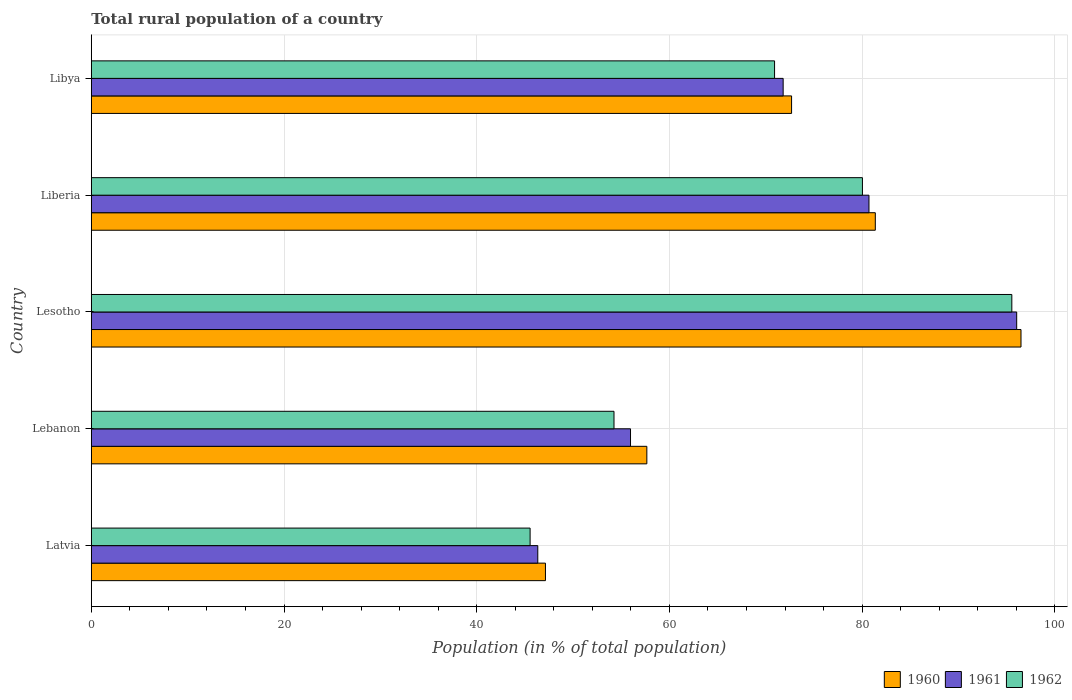How many groups of bars are there?
Provide a short and direct response. 5. Are the number of bars per tick equal to the number of legend labels?
Offer a terse response. Yes. Are the number of bars on each tick of the Y-axis equal?
Your answer should be very brief. Yes. How many bars are there on the 1st tick from the top?
Your answer should be very brief. 3. What is the label of the 4th group of bars from the top?
Give a very brief answer. Lebanon. What is the rural population in 1961 in Lesotho?
Offer a terse response. 96.04. Across all countries, what is the maximum rural population in 1961?
Your answer should be very brief. 96.04. Across all countries, what is the minimum rural population in 1961?
Your answer should be compact. 46.34. In which country was the rural population in 1962 maximum?
Ensure brevity in your answer.  Lesotho. In which country was the rural population in 1960 minimum?
Offer a terse response. Latvia. What is the total rural population in 1961 in the graph?
Provide a short and direct response. 350.85. What is the difference between the rural population in 1961 in Latvia and that in Lebanon?
Give a very brief answer. -9.62. What is the difference between the rural population in 1960 in Lesotho and the rural population in 1961 in Lebanon?
Make the answer very short. 40.53. What is the average rural population in 1960 per country?
Your answer should be very brief. 71.06. What is the difference between the rural population in 1960 and rural population in 1962 in Lebanon?
Your answer should be compact. 3.41. What is the ratio of the rural population in 1961 in Liberia to that in Libya?
Your response must be concise. 1.12. Is the difference between the rural population in 1960 in Lesotho and Liberia greater than the difference between the rural population in 1962 in Lesotho and Liberia?
Provide a succinct answer. No. What is the difference between the highest and the second highest rural population in 1961?
Provide a succinct answer. 15.33. What is the difference between the highest and the lowest rural population in 1962?
Ensure brevity in your answer.  50. In how many countries, is the rural population in 1960 greater than the average rural population in 1960 taken over all countries?
Make the answer very short. 3. Is the sum of the rural population in 1960 in Lesotho and Libya greater than the maximum rural population in 1961 across all countries?
Offer a terse response. Yes. Is it the case that in every country, the sum of the rural population in 1961 and rural population in 1960 is greater than the rural population in 1962?
Make the answer very short. Yes. How many bars are there?
Provide a succinct answer. 15. What is the difference between two consecutive major ticks on the X-axis?
Make the answer very short. 20. Does the graph contain grids?
Keep it short and to the point. Yes. How many legend labels are there?
Your answer should be compact. 3. How are the legend labels stacked?
Ensure brevity in your answer.  Horizontal. What is the title of the graph?
Your answer should be very brief. Total rural population of a country. Does "1979" appear as one of the legend labels in the graph?
Provide a short and direct response. No. What is the label or title of the X-axis?
Ensure brevity in your answer.  Population (in % of total population). What is the label or title of the Y-axis?
Provide a succinct answer. Country. What is the Population (in % of total population) of 1960 in Latvia?
Provide a short and direct response. 47.13. What is the Population (in % of total population) in 1961 in Latvia?
Make the answer very short. 46.34. What is the Population (in % of total population) of 1962 in Latvia?
Your answer should be very brief. 45.54. What is the Population (in % of total population) of 1960 in Lebanon?
Make the answer very short. 57.66. What is the Population (in % of total population) in 1961 in Lebanon?
Give a very brief answer. 55.96. What is the Population (in % of total population) in 1962 in Lebanon?
Make the answer very short. 54.25. What is the Population (in % of total population) in 1960 in Lesotho?
Your response must be concise. 96.49. What is the Population (in % of total population) in 1961 in Lesotho?
Provide a short and direct response. 96.04. What is the Population (in % of total population) in 1962 in Lesotho?
Make the answer very short. 95.54. What is the Population (in % of total population) in 1960 in Liberia?
Give a very brief answer. 81.37. What is the Population (in % of total population) in 1961 in Liberia?
Provide a succinct answer. 80.71. What is the Population (in % of total population) in 1962 in Liberia?
Keep it short and to the point. 80.03. What is the Population (in % of total population) of 1960 in Libya?
Keep it short and to the point. 72.68. What is the Population (in % of total population) of 1961 in Libya?
Your response must be concise. 71.8. What is the Population (in % of total population) in 1962 in Libya?
Your response must be concise. 70.91. Across all countries, what is the maximum Population (in % of total population) of 1960?
Keep it short and to the point. 96.49. Across all countries, what is the maximum Population (in % of total population) in 1961?
Make the answer very short. 96.04. Across all countries, what is the maximum Population (in % of total population) in 1962?
Make the answer very short. 95.54. Across all countries, what is the minimum Population (in % of total population) in 1960?
Give a very brief answer. 47.13. Across all countries, what is the minimum Population (in % of total population) of 1961?
Your answer should be compact. 46.34. Across all countries, what is the minimum Population (in % of total population) of 1962?
Offer a terse response. 45.54. What is the total Population (in % of total population) of 1960 in the graph?
Your answer should be very brief. 355.32. What is the total Population (in % of total population) of 1961 in the graph?
Offer a very short reply. 350.85. What is the total Population (in % of total population) of 1962 in the graph?
Ensure brevity in your answer.  346.27. What is the difference between the Population (in % of total population) in 1960 in Latvia and that in Lebanon?
Your answer should be very brief. -10.52. What is the difference between the Population (in % of total population) in 1961 in Latvia and that in Lebanon?
Give a very brief answer. -9.62. What is the difference between the Population (in % of total population) in 1962 in Latvia and that in Lebanon?
Offer a very short reply. -8.71. What is the difference between the Population (in % of total population) in 1960 in Latvia and that in Lesotho?
Your answer should be very brief. -49.35. What is the difference between the Population (in % of total population) in 1961 in Latvia and that in Lesotho?
Offer a very short reply. -49.7. What is the difference between the Population (in % of total population) in 1962 in Latvia and that in Lesotho?
Your response must be concise. -49.99. What is the difference between the Population (in % of total population) of 1960 in Latvia and that in Liberia?
Your answer should be compact. -34.23. What is the difference between the Population (in % of total population) in 1961 in Latvia and that in Liberia?
Ensure brevity in your answer.  -34.37. What is the difference between the Population (in % of total population) of 1962 in Latvia and that in Liberia?
Make the answer very short. -34.49. What is the difference between the Population (in % of total population) of 1960 in Latvia and that in Libya?
Provide a succinct answer. -25.54. What is the difference between the Population (in % of total population) of 1961 in Latvia and that in Libya?
Your response must be concise. -25.47. What is the difference between the Population (in % of total population) in 1962 in Latvia and that in Libya?
Offer a very short reply. -25.37. What is the difference between the Population (in % of total population) in 1960 in Lebanon and that in Lesotho?
Your answer should be compact. -38.83. What is the difference between the Population (in % of total population) of 1961 in Lebanon and that in Lesotho?
Provide a succinct answer. -40.08. What is the difference between the Population (in % of total population) in 1962 in Lebanon and that in Lesotho?
Keep it short and to the point. -41.29. What is the difference between the Population (in % of total population) of 1960 in Lebanon and that in Liberia?
Your answer should be compact. -23.71. What is the difference between the Population (in % of total population) in 1961 in Lebanon and that in Liberia?
Provide a short and direct response. -24.75. What is the difference between the Population (in % of total population) of 1962 in Lebanon and that in Liberia?
Make the answer very short. -25.78. What is the difference between the Population (in % of total population) of 1960 in Lebanon and that in Libya?
Offer a very short reply. -15.02. What is the difference between the Population (in % of total population) of 1961 in Lebanon and that in Libya?
Provide a short and direct response. -15.84. What is the difference between the Population (in % of total population) in 1962 in Lebanon and that in Libya?
Provide a short and direct response. -16.66. What is the difference between the Population (in % of total population) in 1960 in Lesotho and that in Liberia?
Your answer should be very brief. 15.12. What is the difference between the Population (in % of total population) of 1961 in Lesotho and that in Liberia?
Offer a very short reply. 15.33. What is the difference between the Population (in % of total population) in 1962 in Lesotho and that in Liberia?
Offer a very short reply. 15.51. What is the difference between the Population (in % of total population) in 1960 in Lesotho and that in Libya?
Your answer should be compact. 23.81. What is the difference between the Population (in % of total population) of 1961 in Lesotho and that in Libya?
Your response must be concise. 24.24. What is the difference between the Population (in % of total population) of 1962 in Lesotho and that in Libya?
Offer a terse response. 24.62. What is the difference between the Population (in % of total population) of 1960 in Liberia and that in Libya?
Your answer should be compact. 8.69. What is the difference between the Population (in % of total population) of 1961 in Liberia and that in Libya?
Your answer should be very brief. 8.91. What is the difference between the Population (in % of total population) of 1962 in Liberia and that in Libya?
Your response must be concise. 9.12. What is the difference between the Population (in % of total population) of 1960 in Latvia and the Population (in % of total population) of 1961 in Lebanon?
Your answer should be compact. -8.83. What is the difference between the Population (in % of total population) in 1960 in Latvia and the Population (in % of total population) in 1962 in Lebanon?
Your answer should be very brief. -7.12. What is the difference between the Population (in % of total population) of 1961 in Latvia and the Population (in % of total population) of 1962 in Lebanon?
Your response must be concise. -7.91. What is the difference between the Population (in % of total population) of 1960 in Latvia and the Population (in % of total population) of 1961 in Lesotho?
Offer a terse response. -48.91. What is the difference between the Population (in % of total population) in 1960 in Latvia and the Population (in % of total population) in 1962 in Lesotho?
Offer a terse response. -48.4. What is the difference between the Population (in % of total population) of 1961 in Latvia and the Population (in % of total population) of 1962 in Lesotho?
Your answer should be very brief. -49.2. What is the difference between the Population (in % of total population) of 1960 in Latvia and the Population (in % of total population) of 1961 in Liberia?
Provide a succinct answer. -33.58. What is the difference between the Population (in % of total population) in 1960 in Latvia and the Population (in % of total population) in 1962 in Liberia?
Your answer should be compact. -32.9. What is the difference between the Population (in % of total population) of 1961 in Latvia and the Population (in % of total population) of 1962 in Liberia?
Your response must be concise. -33.69. What is the difference between the Population (in % of total population) in 1960 in Latvia and the Population (in % of total population) in 1961 in Libya?
Keep it short and to the point. -24.67. What is the difference between the Population (in % of total population) of 1960 in Latvia and the Population (in % of total population) of 1962 in Libya?
Provide a short and direct response. -23.78. What is the difference between the Population (in % of total population) of 1961 in Latvia and the Population (in % of total population) of 1962 in Libya?
Ensure brevity in your answer.  -24.57. What is the difference between the Population (in % of total population) of 1960 in Lebanon and the Population (in % of total population) of 1961 in Lesotho?
Provide a succinct answer. -38.38. What is the difference between the Population (in % of total population) in 1960 in Lebanon and the Population (in % of total population) in 1962 in Lesotho?
Provide a succinct answer. -37.88. What is the difference between the Population (in % of total population) of 1961 in Lebanon and the Population (in % of total population) of 1962 in Lesotho?
Give a very brief answer. -39.58. What is the difference between the Population (in % of total population) of 1960 in Lebanon and the Population (in % of total population) of 1961 in Liberia?
Provide a short and direct response. -23.05. What is the difference between the Population (in % of total population) in 1960 in Lebanon and the Population (in % of total population) in 1962 in Liberia?
Keep it short and to the point. -22.37. What is the difference between the Population (in % of total population) in 1961 in Lebanon and the Population (in % of total population) in 1962 in Liberia?
Make the answer very short. -24.07. What is the difference between the Population (in % of total population) of 1960 in Lebanon and the Population (in % of total population) of 1961 in Libya?
Your answer should be compact. -14.15. What is the difference between the Population (in % of total population) of 1960 in Lebanon and the Population (in % of total population) of 1962 in Libya?
Give a very brief answer. -13.25. What is the difference between the Population (in % of total population) in 1961 in Lebanon and the Population (in % of total population) in 1962 in Libya?
Offer a terse response. -14.95. What is the difference between the Population (in % of total population) of 1960 in Lesotho and the Population (in % of total population) of 1961 in Liberia?
Provide a succinct answer. 15.78. What is the difference between the Population (in % of total population) in 1960 in Lesotho and the Population (in % of total population) in 1962 in Liberia?
Provide a succinct answer. 16.46. What is the difference between the Population (in % of total population) of 1961 in Lesotho and the Population (in % of total population) of 1962 in Liberia?
Your answer should be compact. 16.01. What is the difference between the Population (in % of total population) in 1960 in Lesotho and the Population (in % of total population) in 1961 in Libya?
Keep it short and to the point. 24.68. What is the difference between the Population (in % of total population) of 1960 in Lesotho and the Population (in % of total population) of 1962 in Libya?
Provide a succinct answer. 25.58. What is the difference between the Population (in % of total population) of 1961 in Lesotho and the Population (in % of total population) of 1962 in Libya?
Keep it short and to the point. 25.13. What is the difference between the Population (in % of total population) of 1960 in Liberia and the Population (in % of total population) of 1961 in Libya?
Your response must be concise. 9.56. What is the difference between the Population (in % of total population) of 1960 in Liberia and the Population (in % of total population) of 1962 in Libya?
Your response must be concise. 10.46. What is the difference between the Population (in % of total population) of 1961 in Liberia and the Population (in % of total population) of 1962 in Libya?
Your answer should be compact. 9.8. What is the average Population (in % of total population) of 1960 per country?
Your response must be concise. 71.06. What is the average Population (in % of total population) in 1961 per country?
Offer a very short reply. 70.17. What is the average Population (in % of total population) of 1962 per country?
Ensure brevity in your answer.  69.25. What is the difference between the Population (in % of total population) in 1960 and Population (in % of total population) in 1961 in Latvia?
Provide a short and direct response. 0.8. What is the difference between the Population (in % of total population) of 1960 and Population (in % of total population) of 1962 in Latvia?
Make the answer very short. 1.59. What is the difference between the Population (in % of total population) of 1961 and Population (in % of total population) of 1962 in Latvia?
Your answer should be compact. 0.8. What is the difference between the Population (in % of total population) in 1960 and Population (in % of total population) in 1961 in Lebanon?
Offer a terse response. 1.7. What is the difference between the Population (in % of total population) of 1960 and Population (in % of total population) of 1962 in Lebanon?
Offer a terse response. 3.41. What is the difference between the Population (in % of total population) in 1961 and Population (in % of total population) in 1962 in Lebanon?
Keep it short and to the point. 1.71. What is the difference between the Population (in % of total population) of 1960 and Population (in % of total population) of 1961 in Lesotho?
Offer a terse response. 0.45. What is the difference between the Population (in % of total population) of 1960 and Population (in % of total population) of 1962 in Lesotho?
Keep it short and to the point. 0.95. What is the difference between the Population (in % of total population) in 1961 and Population (in % of total population) in 1962 in Lesotho?
Offer a very short reply. 0.5. What is the difference between the Population (in % of total population) of 1960 and Population (in % of total population) of 1961 in Liberia?
Give a very brief answer. 0.66. What is the difference between the Population (in % of total population) in 1960 and Population (in % of total population) in 1962 in Liberia?
Make the answer very short. 1.34. What is the difference between the Population (in % of total population) in 1961 and Population (in % of total population) in 1962 in Liberia?
Keep it short and to the point. 0.68. What is the difference between the Population (in % of total population) of 1960 and Population (in % of total population) of 1961 in Libya?
Ensure brevity in your answer.  0.87. What is the difference between the Population (in % of total population) in 1960 and Population (in % of total population) in 1962 in Libya?
Your response must be concise. 1.77. What is the difference between the Population (in % of total population) of 1961 and Population (in % of total population) of 1962 in Libya?
Offer a very short reply. 0.89. What is the ratio of the Population (in % of total population) in 1960 in Latvia to that in Lebanon?
Ensure brevity in your answer.  0.82. What is the ratio of the Population (in % of total population) of 1961 in Latvia to that in Lebanon?
Your answer should be compact. 0.83. What is the ratio of the Population (in % of total population) in 1962 in Latvia to that in Lebanon?
Give a very brief answer. 0.84. What is the ratio of the Population (in % of total population) of 1960 in Latvia to that in Lesotho?
Ensure brevity in your answer.  0.49. What is the ratio of the Population (in % of total population) in 1961 in Latvia to that in Lesotho?
Your answer should be compact. 0.48. What is the ratio of the Population (in % of total population) in 1962 in Latvia to that in Lesotho?
Offer a terse response. 0.48. What is the ratio of the Population (in % of total population) in 1960 in Latvia to that in Liberia?
Keep it short and to the point. 0.58. What is the ratio of the Population (in % of total population) in 1961 in Latvia to that in Liberia?
Give a very brief answer. 0.57. What is the ratio of the Population (in % of total population) in 1962 in Latvia to that in Liberia?
Provide a short and direct response. 0.57. What is the ratio of the Population (in % of total population) of 1960 in Latvia to that in Libya?
Your answer should be compact. 0.65. What is the ratio of the Population (in % of total population) of 1961 in Latvia to that in Libya?
Make the answer very short. 0.65. What is the ratio of the Population (in % of total population) in 1962 in Latvia to that in Libya?
Make the answer very short. 0.64. What is the ratio of the Population (in % of total population) in 1960 in Lebanon to that in Lesotho?
Give a very brief answer. 0.6. What is the ratio of the Population (in % of total population) in 1961 in Lebanon to that in Lesotho?
Provide a short and direct response. 0.58. What is the ratio of the Population (in % of total population) of 1962 in Lebanon to that in Lesotho?
Offer a very short reply. 0.57. What is the ratio of the Population (in % of total population) in 1960 in Lebanon to that in Liberia?
Make the answer very short. 0.71. What is the ratio of the Population (in % of total population) of 1961 in Lebanon to that in Liberia?
Your response must be concise. 0.69. What is the ratio of the Population (in % of total population) in 1962 in Lebanon to that in Liberia?
Keep it short and to the point. 0.68. What is the ratio of the Population (in % of total population) of 1960 in Lebanon to that in Libya?
Offer a very short reply. 0.79. What is the ratio of the Population (in % of total population) of 1961 in Lebanon to that in Libya?
Your answer should be very brief. 0.78. What is the ratio of the Population (in % of total population) of 1962 in Lebanon to that in Libya?
Provide a short and direct response. 0.77. What is the ratio of the Population (in % of total population) of 1960 in Lesotho to that in Liberia?
Offer a terse response. 1.19. What is the ratio of the Population (in % of total population) in 1961 in Lesotho to that in Liberia?
Ensure brevity in your answer.  1.19. What is the ratio of the Population (in % of total population) of 1962 in Lesotho to that in Liberia?
Provide a succinct answer. 1.19. What is the ratio of the Population (in % of total population) in 1960 in Lesotho to that in Libya?
Offer a terse response. 1.33. What is the ratio of the Population (in % of total population) in 1961 in Lesotho to that in Libya?
Make the answer very short. 1.34. What is the ratio of the Population (in % of total population) of 1962 in Lesotho to that in Libya?
Offer a terse response. 1.35. What is the ratio of the Population (in % of total population) in 1960 in Liberia to that in Libya?
Make the answer very short. 1.12. What is the ratio of the Population (in % of total population) of 1961 in Liberia to that in Libya?
Keep it short and to the point. 1.12. What is the ratio of the Population (in % of total population) in 1962 in Liberia to that in Libya?
Make the answer very short. 1.13. What is the difference between the highest and the second highest Population (in % of total population) in 1960?
Your response must be concise. 15.12. What is the difference between the highest and the second highest Population (in % of total population) of 1961?
Make the answer very short. 15.33. What is the difference between the highest and the second highest Population (in % of total population) in 1962?
Give a very brief answer. 15.51. What is the difference between the highest and the lowest Population (in % of total population) in 1960?
Provide a short and direct response. 49.35. What is the difference between the highest and the lowest Population (in % of total population) in 1961?
Offer a very short reply. 49.7. What is the difference between the highest and the lowest Population (in % of total population) of 1962?
Provide a short and direct response. 49.99. 